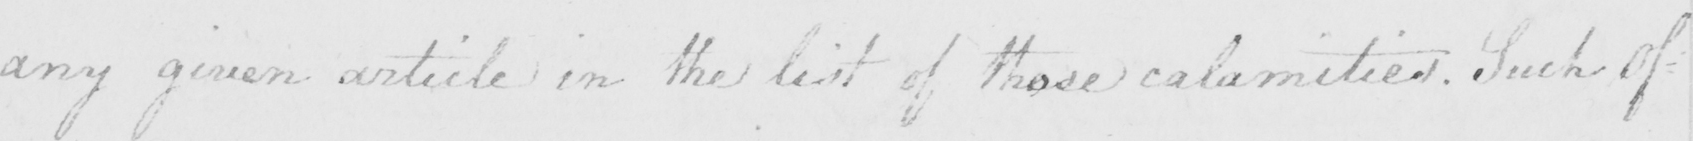Can you tell me what this handwritten text says? any given article in the list of those calamities . Such of- 